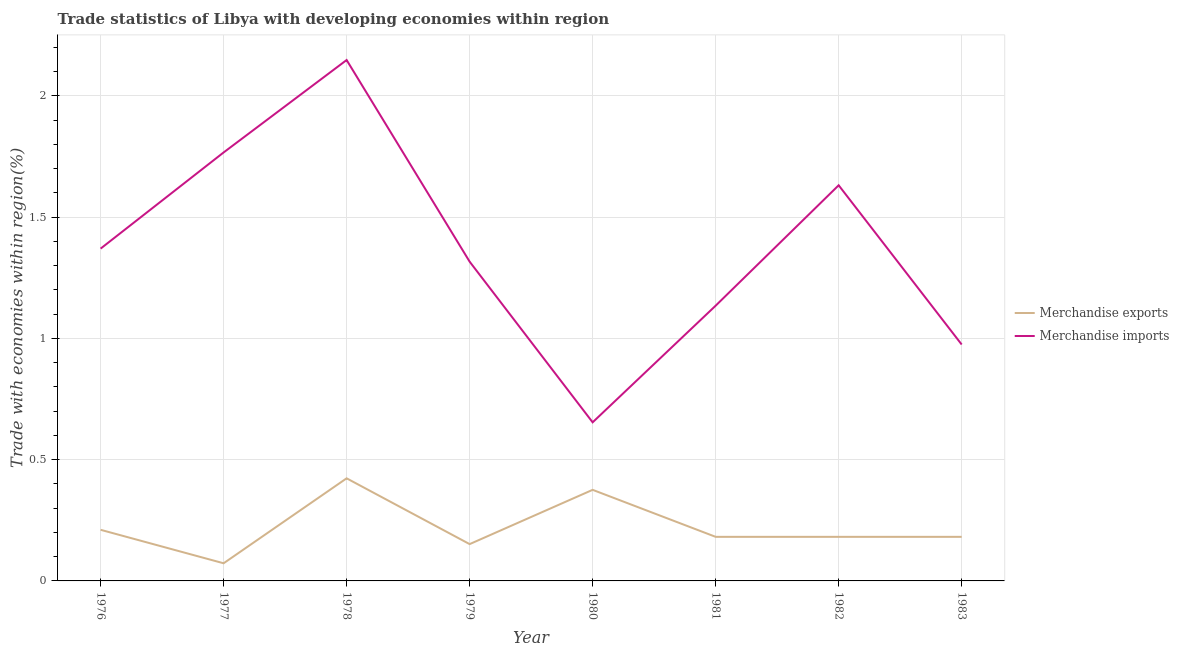What is the merchandise exports in 1976?
Ensure brevity in your answer.  0.21. Across all years, what is the maximum merchandise imports?
Offer a terse response. 2.15. Across all years, what is the minimum merchandise exports?
Your answer should be compact. 0.07. In which year was the merchandise exports maximum?
Provide a succinct answer. 1978. In which year was the merchandise exports minimum?
Your response must be concise. 1977. What is the total merchandise imports in the graph?
Provide a succinct answer. 10.99. What is the difference between the merchandise exports in 1977 and that in 1980?
Give a very brief answer. -0.3. What is the difference between the merchandise exports in 1979 and the merchandise imports in 1981?
Your answer should be compact. -0.98. What is the average merchandise imports per year?
Provide a succinct answer. 1.37. In the year 1978, what is the difference between the merchandise exports and merchandise imports?
Offer a terse response. -1.72. In how many years, is the merchandise exports greater than 2.1 %?
Your answer should be compact. 0. What is the ratio of the merchandise exports in 1978 to that in 1982?
Keep it short and to the point. 2.33. Is the merchandise imports in 1976 less than that in 1979?
Provide a short and direct response. No. Is the difference between the merchandise exports in 1977 and 1980 greater than the difference between the merchandise imports in 1977 and 1980?
Give a very brief answer. No. What is the difference between the highest and the second highest merchandise imports?
Make the answer very short. 0.38. What is the difference between the highest and the lowest merchandise exports?
Ensure brevity in your answer.  0.35. Is the merchandise exports strictly less than the merchandise imports over the years?
Offer a very short reply. Yes. How many years are there in the graph?
Your answer should be compact. 8. What is the difference between two consecutive major ticks on the Y-axis?
Your answer should be compact. 0.5. Are the values on the major ticks of Y-axis written in scientific E-notation?
Ensure brevity in your answer.  No. Does the graph contain any zero values?
Offer a very short reply. No. How many legend labels are there?
Offer a very short reply. 2. What is the title of the graph?
Keep it short and to the point. Trade statistics of Libya with developing economies within region. Does "Diarrhea" appear as one of the legend labels in the graph?
Give a very brief answer. No. What is the label or title of the X-axis?
Make the answer very short. Year. What is the label or title of the Y-axis?
Provide a succinct answer. Trade with economies within region(%). What is the Trade with economies within region(%) in Merchandise exports in 1976?
Provide a short and direct response. 0.21. What is the Trade with economies within region(%) in Merchandise imports in 1976?
Offer a very short reply. 1.37. What is the Trade with economies within region(%) of Merchandise exports in 1977?
Your answer should be compact. 0.07. What is the Trade with economies within region(%) in Merchandise imports in 1977?
Your answer should be very brief. 1.77. What is the Trade with economies within region(%) of Merchandise exports in 1978?
Your answer should be very brief. 0.42. What is the Trade with economies within region(%) of Merchandise imports in 1978?
Ensure brevity in your answer.  2.15. What is the Trade with economies within region(%) of Merchandise exports in 1979?
Make the answer very short. 0.15. What is the Trade with economies within region(%) of Merchandise imports in 1979?
Provide a short and direct response. 1.32. What is the Trade with economies within region(%) in Merchandise exports in 1980?
Offer a very short reply. 0.38. What is the Trade with economies within region(%) in Merchandise imports in 1980?
Make the answer very short. 0.65. What is the Trade with economies within region(%) of Merchandise exports in 1981?
Your answer should be very brief. 0.18. What is the Trade with economies within region(%) in Merchandise imports in 1981?
Ensure brevity in your answer.  1.13. What is the Trade with economies within region(%) of Merchandise exports in 1982?
Your answer should be compact. 0.18. What is the Trade with economies within region(%) in Merchandise imports in 1982?
Your response must be concise. 1.63. What is the Trade with economies within region(%) of Merchandise exports in 1983?
Provide a succinct answer. 0.18. What is the Trade with economies within region(%) in Merchandise imports in 1983?
Keep it short and to the point. 0.97. Across all years, what is the maximum Trade with economies within region(%) in Merchandise exports?
Offer a terse response. 0.42. Across all years, what is the maximum Trade with economies within region(%) in Merchandise imports?
Give a very brief answer. 2.15. Across all years, what is the minimum Trade with economies within region(%) in Merchandise exports?
Your response must be concise. 0.07. Across all years, what is the minimum Trade with economies within region(%) of Merchandise imports?
Keep it short and to the point. 0.65. What is the total Trade with economies within region(%) in Merchandise exports in the graph?
Your response must be concise. 1.78. What is the total Trade with economies within region(%) of Merchandise imports in the graph?
Offer a terse response. 10.99. What is the difference between the Trade with economies within region(%) of Merchandise exports in 1976 and that in 1977?
Offer a terse response. 0.14. What is the difference between the Trade with economies within region(%) of Merchandise imports in 1976 and that in 1977?
Keep it short and to the point. -0.4. What is the difference between the Trade with economies within region(%) in Merchandise exports in 1976 and that in 1978?
Offer a terse response. -0.21. What is the difference between the Trade with economies within region(%) in Merchandise imports in 1976 and that in 1978?
Your response must be concise. -0.78. What is the difference between the Trade with economies within region(%) of Merchandise exports in 1976 and that in 1979?
Your answer should be compact. 0.06. What is the difference between the Trade with economies within region(%) in Merchandise imports in 1976 and that in 1979?
Offer a very short reply. 0.05. What is the difference between the Trade with economies within region(%) of Merchandise exports in 1976 and that in 1980?
Give a very brief answer. -0.16. What is the difference between the Trade with economies within region(%) in Merchandise imports in 1976 and that in 1980?
Offer a very short reply. 0.72. What is the difference between the Trade with economies within region(%) of Merchandise exports in 1976 and that in 1981?
Give a very brief answer. 0.03. What is the difference between the Trade with economies within region(%) of Merchandise imports in 1976 and that in 1981?
Ensure brevity in your answer.  0.24. What is the difference between the Trade with economies within region(%) in Merchandise exports in 1976 and that in 1982?
Make the answer very short. 0.03. What is the difference between the Trade with economies within region(%) in Merchandise imports in 1976 and that in 1982?
Ensure brevity in your answer.  -0.26. What is the difference between the Trade with economies within region(%) of Merchandise exports in 1976 and that in 1983?
Your answer should be compact. 0.03. What is the difference between the Trade with economies within region(%) in Merchandise imports in 1976 and that in 1983?
Keep it short and to the point. 0.4. What is the difference between the Trade with economies within region(%) in Merchandise exports in 1977 and that in 1978?
Offer a terse response. -0.35. What is the difference between the Trade with economies within region(%) in Merchandise imports in 1977 and that in 1978?
Your response must be concise. -0.38. What is the difference between the Trade with economies within region(%) in Merchandise exports in 1977 and that in 1979?
Provide a short and direct response. -0.08. What is the difference between the Trade with economies within region(%) of Merchandise imports in 1977 and that in 1979?
Provide a short and direct response. 0.45. What is the difference between the Trade with economies within region(%) in Merchandise exports in 1977 and that in 1980?
Your answer should be compact. -0.3. What is the difference between the Trade with economies within region(%) of Merchandise imports in 1977 and that in 1980?
Offer a very short reply. 1.11. What is the difference between the Trade with economies within region(%) in Merchandise exports in 1977 and that in 1981?
Make the answer very short. -0.11. What is the difference between the Trade with economies within region(%) of Merchandise imports in 1977 and that in 1981?
Make the answer very short. 0.63. What is the difference between the Trade with economies within region(%) of Merchandise exports in 1977 and that in 1982?
Offer a terse response. -0.11. What is the difference between the Trade with economies within region(%) in Merchandise imports in 1977 and that in 1982?
Offer a terse response. 0.14. What is the difference between the Trade with economies within region(%) in Merchandise exports in 1977 and that in 1983?
Keep it short and to the point. -0.11. What is the difference between the Trade with economies within region(%) in Merchandise imports in 1977 and that in 1983?
Offer a terse response. 0.79. What is the difference between the Trade with economies within region(%) of Merchandise exports in 1978 and that in 1979?
Make the answer very short. 0.27. What is the difference between the Trade with economies within region(%) in Merchandise imports in 1978 and that in 1979?
Provide a succinct answer. 0.83. What is the difference between the Trade with economies within region(%) of Merchandise exports in 1978 and that in 1980?
Offer a very short reply. 0.05. What is the difference between the Trade with economies within region(%) in Merchandise imports in 1978 and that in 1980?
Make the answer very short. 1.49. What is the difference between the Trade with economies within region(%) in Merchandise exports in 1978 and that in 1981?
Your response must be concise. 0.24. What is the difference between the Trade with economies within region(%) of Merchandise imports in 1978 and that in 1981?
Give a very brief answer. 1.01. What is the difference between the Trade with economies within region(%) of Merchandise exports in 1978 and that in 1982?
Your answer should be compact. 0.24. What is the difference between the Trade with economies within region(%) in Merchandise imports in 1978 and that in 1982?
Your response must be concise. 0.52. What is the difference between the Trade with economies within region(%) in Merchandise exports in 1978 and that in 1983?
Provide a short and direct response. 0.24. What is the difference between the Trade with economies within region(%) of Merchandise imports in 1978 and that in 1983?
Ensure brevity in your answer.  1.17. What is the difference between the Trade with economies within region(%) in Merchandise exports in 1979 and that in 1980?
Provide a short and direct response. -0.22. What is the difference between the Trade with economies within region(%) in Merchandise imports in 1979 and that in 1980?
Provide a succinct answer. 0.66. What is the difference between the Trade with economies within region(%) in Merchandise exports in 1979 and that in 1981?
Provide a short and direct response. -0.03. What is the difference between the Trade with economies within region(%) of Merchandise imports in 1979 and that in 1981?
Your response must be concise. 0.18. What is the difference between the Trade with economies within region(%) in Merchandise exports in 1979 and that in 1982?
Offer a very short reply. -0.03. What is the difference between the Trade with economies within region(%) in Merchandise imports in 1979 and that in 1982?
Ensure brevity in your answer.  -0.31. What is the difference between the Trade with economies within region(%) in Merchandise exports in 1979 and that in 1983?
Provide a succinct answer. -0.03. What is the difference between the Trade with economies within region(%) of Merchandise imports in 1979 and that in 1983?
Provide a succinct answer. 0.34. What is the difference between the Trade with economies within region(%) of Merchandise exports in 1980 and that in 1981?
Give a very brief answer. 0.19. What is the difference between the Trade with economies within region(%) in Merchandise imports in 1980 and that in 1981?
Your answer should be compact. -0.48. What is the difference between the Trade with economies within region(%) of Merchandise exports in 1980 and that in 1982?
Give a very brief answer. 0.19. What is the difference between the Trade with economies within region(%) in Merchandise imports in 1980 and that in 1982?
Make the answer very short. -0.98. What is the difference between the Trade with economies within region(%) in Merchandise exports in 1980 and that in 1983?
Offer a terse response. 0.19. What is the difference between the Trade with economies within region(%) of Merchandise imports in 1980 and that in 1983?
Your response must be concise. -0.32. What is the difference between the Trade with economies within region(%) in Merchandise exports in 1981 and that in 1982?
Provide a succinct answer. -0. What is the difference between the Trade with economies within region(%) in Merchandise imports in 1981 and that in 1982?
Your response must be concise. -0.5. What is the difference between the Trade with economies within region(%) in Merchandise imports in 1981 and that in 1983?
Ensure brevity in your answer.  0.16. What is the difference between the Trade with economies within region(%) of Merchandise exports in 1982 and that in 1983?
Make the answer very short. 0. What is the difference between the Trade with economies within region(%) in Merchandise imports in 1982 and that in 1983?
Ensure brevity in your answer.  0.66. What is the difference between the Trade with economies within region(%) in Merchandise exports in 1976 and the Trade with economies within region(%) in Merchandise imports in 1977?
Provide a succinct answer. -1.56. What is the difference between the Trade with economies within region(%) of Merchandise exports in 1976 and the Trade with economies within region(%) of Merchandise imports in 1978?
Your response must be concise. -1.94. What is the difference between the Trade with economies within region(%) in Merchandise exports in 1976 and the Trade with economies within region(%) in Merchandise imports in 1979?
Your answer should be compact. -1.11. What is the difference between the Trade with economies within region(%) in Merchandise exports in 1976 and the Trade with economies within region(%) in Merchandise imports in 1980?
Your response must be concise. -0.44. What is the difference between the Trade with economies within region(%) in Merchandise exports in 1976 and the Trade with economies within region(%) in Merchandise imports in 1981?
Ensure brevity in your answer.  -0.92. What is the difference between the Trade with economies within region(%) of Merchandise exports in 1976 and the Trade with economies within region(%) of Merchandise imports in 1982?
Give a very brief answer. -1.42. What is the difference between the Trade with economies within region(%) in Merchandise exports in 1976 and the Trade with economies within region(%) in Merchandise imports in 1983?
Offer a very short reply. -0.76. What is the difference between the Trade with economies within region(%) of Merchandise exports in 1977 and the Trade with economies within region(%) of Merchandise imports in 1978?
Your response must be concise. -2.07. What is the difference between the Trade with economies within region(%) in Merchandise exports in 1977 and the Trade with economies within region(%) in Merchandise imports in 1979?
Ensure brevity in your answer.  -1.24. What is the difference between the Trade with economies within region(%) of Merchandise exports in 1977 and the Trade with economies within region(%) of Merchandise imports in 1980?
Make the answer very short. -0.58. What is the difference between the Trade with economies within region(%) in Merchandise exports in 1977 and the Trade with economies within region(%) in Merchandise imports in 1981?
Your answer should be compact. -1.06. What is the difference between the Trade with economies within region(%) of Merchandise exports in 1977 and the Trade with economies within region(%) of Merchandise imports in 1982?
Offer a very short reply. -1.56. What is the difference between the Trade with economies within region(%) of Merchandise exports in 1977 and the Trade with economies within region(%) of Merchandise imports in 1983?
Your response must be concise. -0.9. What is the difference between the Trade with economies within region(%) of Merchandise exports in 1978 and the Trade with economies within region(%) of Merchandise imports in 1979?
Ensure brevity in your answer.  -0.89. What is the difference between the Trade with economies within region(%) in Merchandise exports in 1978 and the Trade with economies within region(%) in Merchandise imports in 1980?
Provide a succinct answer. -0.23. What is the difference between the Trade with economies within region(%) of Merchandise exports in 1978 and the Trade with economies within region(%) of Merchandise imports in 1981?
Provide a succinct answer. -0.71. What is the difference between the Trade with economies within region(%) in Merchandise exports in 1978 and the Trade with economies within region(%) in Merchandise imports in 1982?
Your answer should be very brief. -1.21. What is the difference between the Trade with economies within region(%) of Merchandise exports in 1978 and the Trade with economies within region(%) of Merchandise imports in 1983?
Provide a succinct answer. -0.55. What is the difference between the Trade with economies within region(%) in Merchandise exports in 1979 and the Trade with economies within region(%) in Merchandise imports in 1980?
Offer a terse response. -0.5. What is the difference between the Trade with economies within region(%) in Merchandise exports in 1979 and the Trade with economies within region(%) in Merchandise imports in 1981?
Keep it short and to the point. -0.98. What is the difference between the Trade with economies within region(%) in Merchandise exports in 1979 and the Trade with economies within region(%) in Merchandise imports in 1982?
Ensure brevity in your answer.  -1.48. What is the difference between the Trade with economies within region(%) in Merchandise exports in 1979 and the Trade with economies within region(%) in Merchandise imports in 1983?
Provide a short and direct response. -0.82. What is the difference between the Trade with economies within region(%) in Merchandise exports in 1980 and the Trade with economies within region(%) in Merchandise imports in 1981?
Provide a succinct answer. -0.76. What is the difference between the Trade with economies within region(%) in Merchandise exports in 1980 and the Trade with economies within region(%) in Merchandise imports in 1982?
Your answer should be very brief. -1.26. What is the difference between the Trade with economies within region(%) of Merchandise exports in 1980 and the Trade with economies within region(%) of Merchandise imports in 1983?
Give a very brief answer. -0.6. What is the difference between the Trade with economies within region(%) in Merchandise exports in 1981 and the Trade with economies within region(%) in Merchandise imports in 1982?
Your response must be concise. -1.45. What is the difference between the Trade with economies within region(%) in Merchandise exports in 1981 and the Trade with economies within region(%) in Merchandise imports in 1983?
Your answer should be compact. -0.79. What is the difference between the Trade with economies within region(%) of Merchandise exports in 1982 and the Trade with economies within region(%) of Merchandise imports in 1983?
Provide a succinct answer. -0.79. What is the average Trade with economies within region(%) in Merchandise exports per year?
Offer a terse response. 0.22. What is the average Trade with economies within region(%) in Merchandise imports per year?
Your answer should be compact. 1.37. In the year 1976, what is the difference between the Trade with economies within region(%) of Merchandise exports and Trade with economies within region(%) of Merchandise imports?
Give a very brief answer. -1.16. In the year 1977, what is the difference between the Trade with economies within region(%) in Merchandise exports and Trade with economies within region(%) in Merchandise imports?
Make the answer very short. -1.69. In the year 1978, what is the difference between the Trade with economies within region(%) of Merchandise exports and Trade with economies within region(%) of Merchandise imports?
Make the answer very short. -1.72. In the year 1979, what is the difference between the Trade with economies within region(%) of Merchandise exports and Trade with economies within region(%) of Merchandise imports?
Your answer should be very brief. -1.16. In the year 1980, what is the difference between the Trade with economies within region(%) of Merchandise exports and Trade with economies within region(%) of Merchandise imports?
Your answer should be compact. -0.28. In the year 1981, what is the difference between the Trade with economies within region(%) of Merchandise exports and Trade with economies within region(%) of Merchandise imports?
Offer a very short reply. -0.95. In the year 1982, what is the difference between the Trade with economies within region(%) of Merchandise exports and Trade with economies within region(%) of Merchandise imports?
Your answer should be compact. -1.45. In the year 1983, what is the difference between the Trade with economies within region(%) of Merchandise exports and Trade with economies within region(%) of Merchandise imports?
Give a very brief answer. -0.79. What is the ratio of the Trade with economies within region(%) of Merchandise exports in 1976 to that in 1977?
Your response must be concise. 2.9. What is the ratio of the Trade with economies within region(%) in Merchandise imports in 1976 to that in 1977?
Provide a succinct answer. 0.78. What is the ratio of the Trade with economies within region(%) in Merchandise exports in 1976 to that in 1978?
Ensure brevity in your answer.  0.5. What is the ratio of the Trade with economies within region(%) in Merchandise imports in 1976 to that in 1978?
Offer a very short reply. 0.64. What is the ratio of the Trade with economies within region(%) of Merchandise exports in 1976 to that in 1979?
Offer a terse response. 1.39. What is the ratio of the Trade with economies within region(%) of Merchandise imports in 1976 to that in 1979?
Give a very brief answer. 1.04. What is the ratio of the Trade with economies within region(%) in Merchandise exports in 1976 to that in 1980?
Provide a succinct answer. 0.56. What is the ratio of the Trade with economies within region(%) in Merchandise imports in 1976 to that in 1980?
Provide a short and direct response. 2.1. What is the ratio of the Trade with economies within region(%) of Merchandise exports in 1976 to that in 1981?
Provide a succinct answer. 1.16. What is the ratio of the Trade with economies within region(%) of Merchandise imports in 1976 to that in 1981?
Ensure brevity in your answer.  1.21. What is the ratio of the Trade with economies within region(%) in Merchandise exports in 1976 to that in 1982?
Keep it short and to the point. 1.16. What is the ratio of the Trade with economies within region(%) in Merchandise imports in 1976 to that in 1982?
Provide a short and direct response. 0.84. What is the ratio of the Trade with economies within region(%) in Merchandise exports in 1976 to that in 1983?
Provide a short and direct response. 1.16. What is the ratio of the Trade with economies within region(%) of Merchandise imports in 1976 to that in 1983?
Your answer should be very brief. 1.41. What is the ratio of the Trade with economies within region(%) of Merchandise exports in 1977 to that in 1978?
Keep it short and to the point. 0.17. What is the ratio of the Trade with economies within region(%) of Merchandise imports in 1977 to that in 1978?
Your response must be concise. 0.82. What is the ratio of the Trade with economies within region(%) in Merchandise exports in 1977 to that in 1979?
Give a very brief answer. 0.48. What is the ratio of the Trade with economies within region(%) of Merchandise imports in 1977 to that in 1979?
Your answer should be compact. 1.34. What is the ratio of the Trade with economies within region(%) of Merchandise exports in 1977 to that in 1980?
Provide a succinct answer. 0.19. What is the ratio of the Trade with economies within region(%) of Merchandise imports in 1977 to that in 1980?
Offer a very short reply. 2.7. What is the ratio of the Trade with economies within region(%) in Merchandise exports in 1977 to that in 1981?
Offer a very short reply. 0.4. What is the ratio of the Trade with economies within region(%) of Merchandise imports in 1977 to that in 1981?
Your response must be concise. 1.56. What is the ratio of the Trade with economies within region(%) of Merchandise exports in 1977 to that in 1982?
Your answer should be compact. 0.4. What is the ratio of the Trade with economies within region(%) in Merchandise imports in 1977 to that in 1982?
Offer a terse response. 1.08. What is the ratio of the Trade with economies within region(%) in Merchandise exports in 1977 to that in 1983?
Your answer should be very brief. 0.4. What is the ratio of the Trade with economies within region(%) in Merchandise imports in 1977 to that in 1983?
Provide a short and direct response. 1.81. What is the ratio of the Trade with economies within region(%) of Merchandise exports in 1978 to that in 1979?
Your answer should be compact. 2.79. What is the ratio of the Trade with economies within region(%) of Merchandise imports in 1978 to that in 1979?
Give a very brief answer. 1.63. What is the ratio of the Trade with economies within region(%) of Merchandise exports in 1978 to that in 1980?
Provide a short and direct response. 1.13. What is the ratio of the Trade with economies within region(%) of Merchandise imports in 1978 to that in 1980?
Give a very brief answer. 3.28. What is the ratio of the Trade with economies within region(%) in Merchandise exports in 1978 to that in 1981?
Keep it short and to the point. 2.33. What is the ratio of the Trade with economies within region(%) of Merchandise imports in 1978 to that in 1981?
Provide a succinct answer. 1.89. What is the ratio of the Trade with economies within region(%) in Merchandise exports in 1978 to that in 1982?
Make the answer very short. 2.33. What is the ratio of the Trade with economies within region(%) of Merchandise imports in 1978 to that in 1982?
Offer a terse response. 1.32. What is the ratio of the Trade with economies within region(%) of Merchandise exports in 1978 to that in 1983?
Your response must be concise. 2.33. What is the ratio of the Trade with economies within region(%) in Merchandise imports in 1978 to that in 1983?
Give a very brief answer. 2.2. What is the ratio of the Trade with economies within region(%) of Merchandise exports in 1979 to that in 1980?
Offer a very short reply. 0.4. What is the ratio of the Trade with economies within region(%) of Merchandise imports in 1979 to that in 1980?
Provide a succinct answer. 2.01. What is the ratio of the Trade with economies within region(%) in Merchandise exports in 1979 to that in 1981?
Offer a terse response. 0.83. What is the ratio of the Trade with economies within region(%) in Merchandise imports in 1979 to that in 1981?
Offer a very short reply. 1.16. What is the ratio of the Trade with economies within region(%) of Merchandise exports in 1979 to that in 1982?
Keep it short and to the point. 0.83. What is the ratio of the Trade with economies within region(%) in Merchandise imports in 1979 to that in 1982?
Keep it short and to the point. 0.81. What is the ratio of the Trade with economies within region(%) in Merchandise exports in 1979 to that in 1983?
Offer a very short reply. 0.83. What is the ratio of the Trade with economies within region(%) in Merchandise imports in 1979 to that in 1983?
Give a very brief answer. 1.35. What is the ratio of the Trade with economies within region(%) of Merchandise exports in 1980 to that in 1981?
Offer a very short reply. 2.07. What is the ratio of the Trade with economies within region(%) in Merchandise imports in 1980 to that in 1981?
Provide a succinct answer. 0.58. What is the ratio of the Trade with economies within region(%) in Merchandise exports in 1980 to that in 1982?
Offer a terse response. 2.07. What is the ratio of the Trade with economies within region(%) in Merchandise imports in 1980 to that in 1982?
Provide a succinct answer. 0.4. What is the ratio of the Trade with economies within region(%) of Merchandise exports in 1980 to that in 1983?
Offer a terse response. 2.07. What is the ratio of the Trade with economies within region(%) of Merchandise imports in 1980 to that in 1983?
Offer a very short reply. 0.67. What is the ratio of the Trade with economies within region(%) in Merchandise exports in 1981 to that in 1982?
Provide a succinct answer. 1. What is the ratio of the Trade with economies within region(%) of Merchandise imports in 1981 to that in 1982?
Provide a short and direct response. 0.7. What is the ratio of the Trade with economies within region(%) of Merchandise imports in 1981 to that in 1983?
Offer a very short reply. 1.16. What is the ratio of the Trade with economies within region(%) of Merchandise imports in 1982 to that in 1983?
Ensure brevity in your answer.  1.67. What is the difference between the highest and the second highest Trade with economies within region(%) of Merchandise exports?
Offer a terse response. 0.05. What is the difference between the highest and the second highest Trade with economies within region(%) of Merchandise imports?
Provide a short and direct response. 0.38. What is the difference between the highest and the lowest Trade with economies within region(%) of Merchandise exports?
Ensure brevity in your answer.  0.35. What is the difference between the highest and the lowest Trade with economies within region(%) in Merchandise imports?
Give a very brief answer. 1.49. 